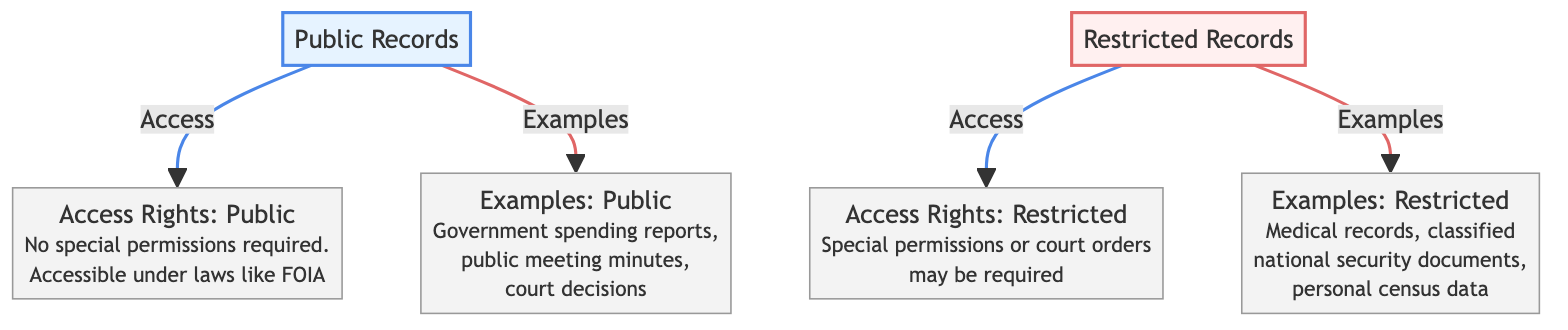What are the two main categories of government records depicted in the diagram? The diagram specifically labels "Public Records" and "Restricted Records" as the two categories, clearly separating them visually with different colors.
Answer: Public Records, Restricted Records What type of access rights is associated with public records? According to the diagram, public records require "No special permissions" and are accessible under laws like FOIA. This is stated under the access rights of the public records.
Answer: No special permissions required How many examples are provided for each category of records? In the diagram, two distinct categories are included, each showing three examples related to their corresponding record type. This counts as a total of three examples for both public and restricted records.
Answer: Three examples What is an example of a restricted record listed in the diagram? The diagram provides three examples for restricted records, which include "Medical records," "classified national security documents," and "personal census data." Each of these illustrates the nature of restricted records.
Answer: Medical records What do the access rights for restricted records require? Within the diagram, it is stated that access rights for restricted records may require "Special permissions or court orders," emphasizing a limited access compared to public records.
Answer: Special permissions or court orders Which color represents public records in the diagram? The diagram uses a light blue fill color (denoted in the code) to visually distinguish public records from restricted records, giving an immediate visual cue to anyone interpreting the diagram.
Answer: Light blue Which government record type has a broader access right according to the diagram? The diagram illustrates that public records have broader access rights as they require no special permissions, whereas restricted records necessitate special permissions or court orders. This information shows the difference in access rights between the two types.
Answer: Public records How many nodes are connected to public records in the diagram? The diagram shows two nodes connected to public records: "Access Rights: Public" and "Examples: Public." Each connection provides detailed sub-information about public records.
Answer: Two nodes 